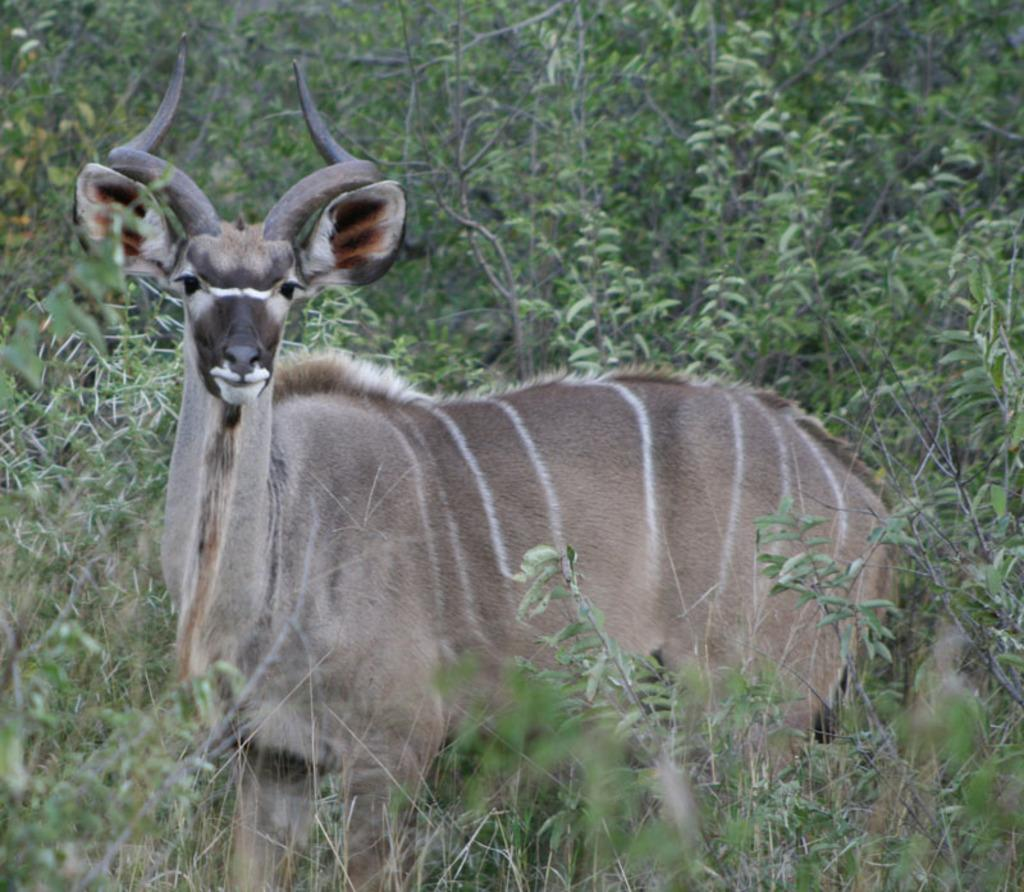What type of creature is in the picture? There is an animal in the picture. Can you describe the color of the animal? The animal is in light brown color. Are there any distinct markings on the animal? Yes, there are white lines on the animal. What can be seen in the background of the picture? There are trees visible in the background of the picture. What type of design can be seen on the flowers in the image? There are no flowers present in the image, so it is not possible to answer that question. 